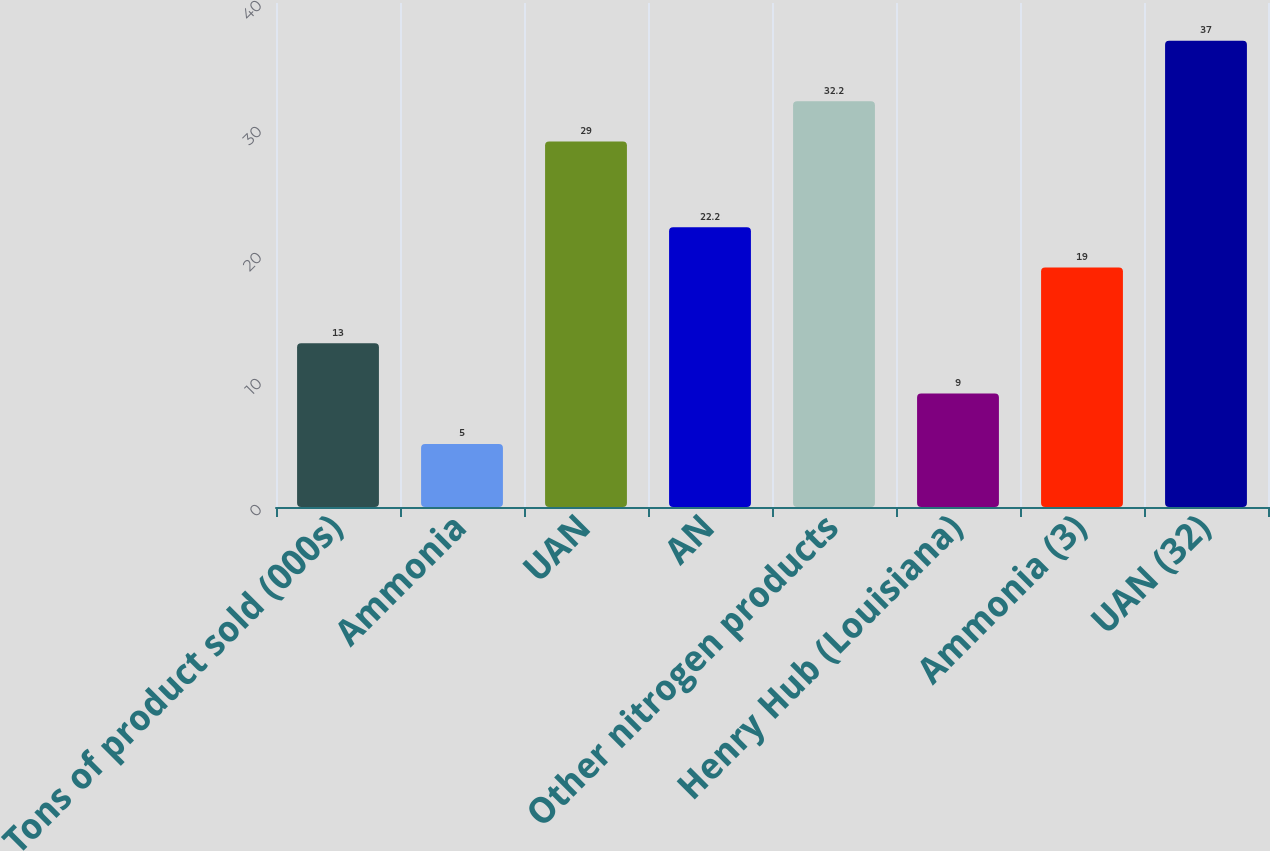Convert chart to OTSL. <chart><loc_0><loc_0><loc_500><loc_500><bar_chart><fcel>Tons of product sold (000s)<fcel>Ammonia<fcel>UAN<fcel>AN<fcel>Other nitrogen products<fcel>Henry Hub (Louisiana)<fcel>Ammonia (3)<fcel>UAN (32)<nl><fcel>13<fcel>5<fcel>29<fcel>22.2<fcel>32.2<fcel>9<fcel>19<fcel>37<nl></chart> 